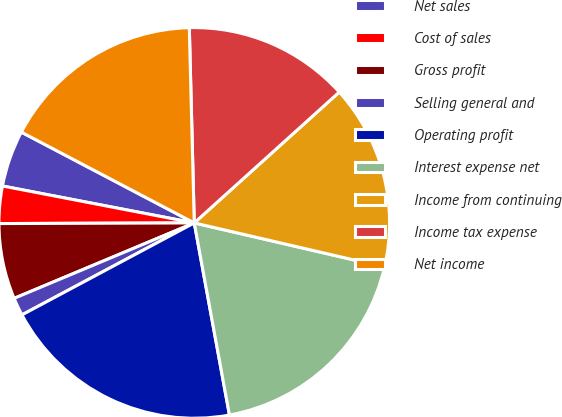Convert chart. <chart><loc_0><loc_0><loc_500><loc_500><pie_chart><fcel>Net sales<fcel>Cost of sales<fcel>Gross profit<fcel>Selling general and<fcel>Operating profit<fcel>Interest expense net<fcel>Income from continuing<fcel>Income tax expense<fcel>Net income<nl><fcel>4.67%<fcel>3.08%<fcel>6.26%<fcel>1.49%<fcel>20.08%<fcel>18.49%<fcel>15.31%<fcel>13.72%<fcel>16.9%<nl></chart> 